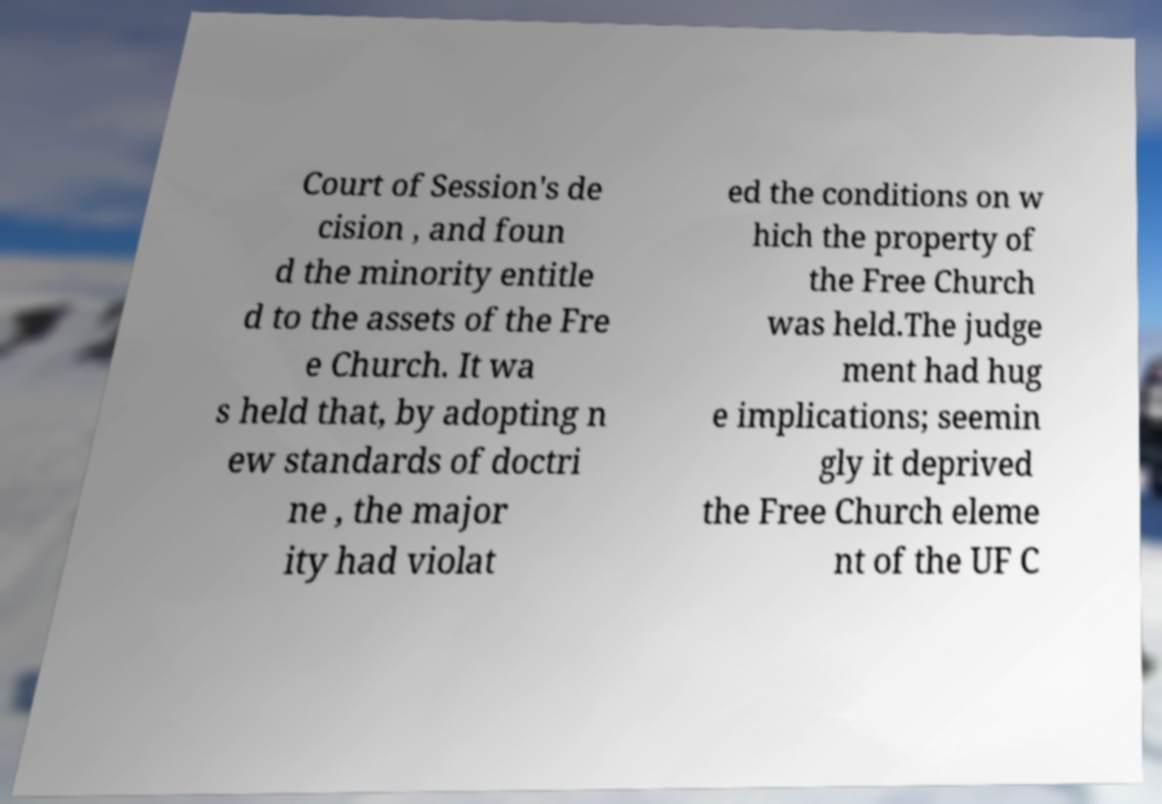For documentation purposes, I need the text within this image transcribed. Could you provide that? Court of Session's de cision , and foun d the minority entitle d to the assets of the Fre e Church. It wa s held that, by adopting n ew standards of doctri ne , the major ity had violat ed the conditions on w hich the property of the Free Church was held.The judge ment had hug e implications; seemin gly it deprived the Free Church eleme nt of the UF C 